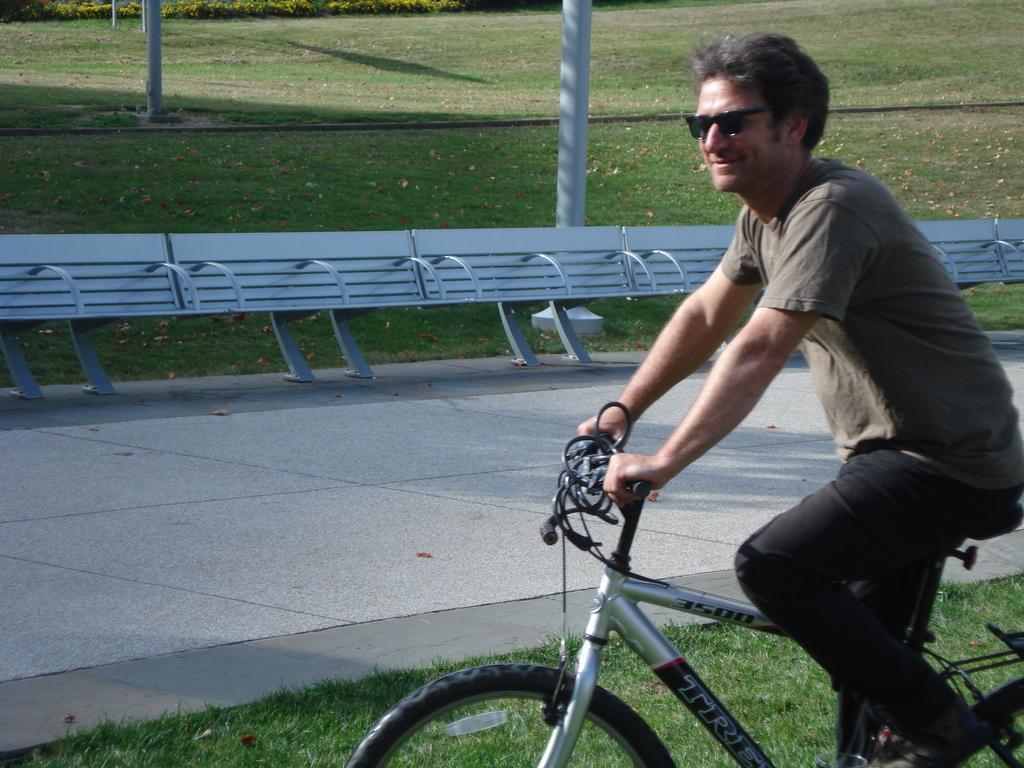Could you give a brief overview of what you see in this image? In this picture a man is smiling and riding a bicycle. 